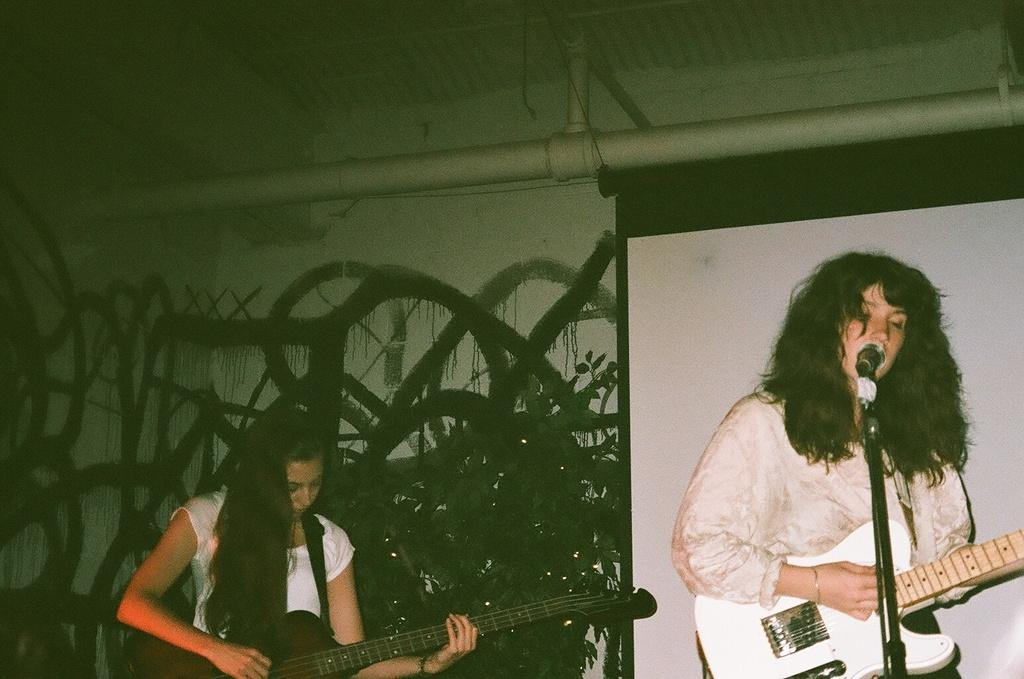What are the two people in the image holding? The two people in the image are holding guitars. How are the guitars being held by the people? The people are holding the guitars in their hands. Can you describe the woman in the image? The woman in the image is standing and singing a song on a microphone. What can be seen in the background of the image? There is a board visible in the background of the image. Can you tell me how many cards the woman is holding in the image? There are no cards visible in the image; the woman is holding a microphone while singing. Is the woman running in the image? The woman is not running in the image; she is standing and singing on a microphone. 